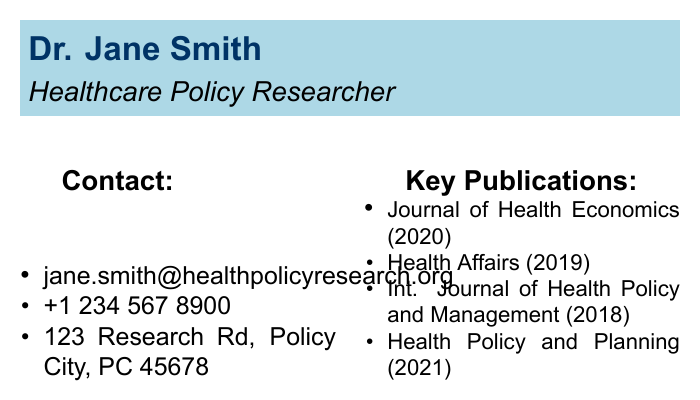What is the name of the researcher? The name is displayed prominently at the top of the document, which is Dr. Jane Smith.
Answer: Dr. Jane Smith What is the email address provided? The email address is listed under the contact section, which is jane.smith@healthpolicyresearch.org.
Answer: jane.smith@healthpolicyresearch.org In which year was the publication in Health Affairs released? The publication date is specified next to the journal name in the key publications section, which is 2019.
Answer: 2019 How many key publications are listed on the card? The total number of key publications can be counted from the list, which includes four entries.
Answer: 4 Which journal was published in 2020? The publication date for the Journal of Health Economics is indicated alongside the title in the key publications section, which is 2020.
Answer: Journal of Health Economics What is the primary area of specialization mentioned? The specialization is found in the text at the bottom of the document, indicating the focus on regulations' impacts on investment decisions.
Answer: Impact of regulations on healthcare investment decisions Which journal was published last among the key publications? The latest publication date in the key publications list is for Health Policy and Planning, which is 2021.
Answer: Health Policy and Planning What is the phone number listed? The phone number is included under the contact information, which is +1 234 567 8900.
Answer: +1 234 567 8900 